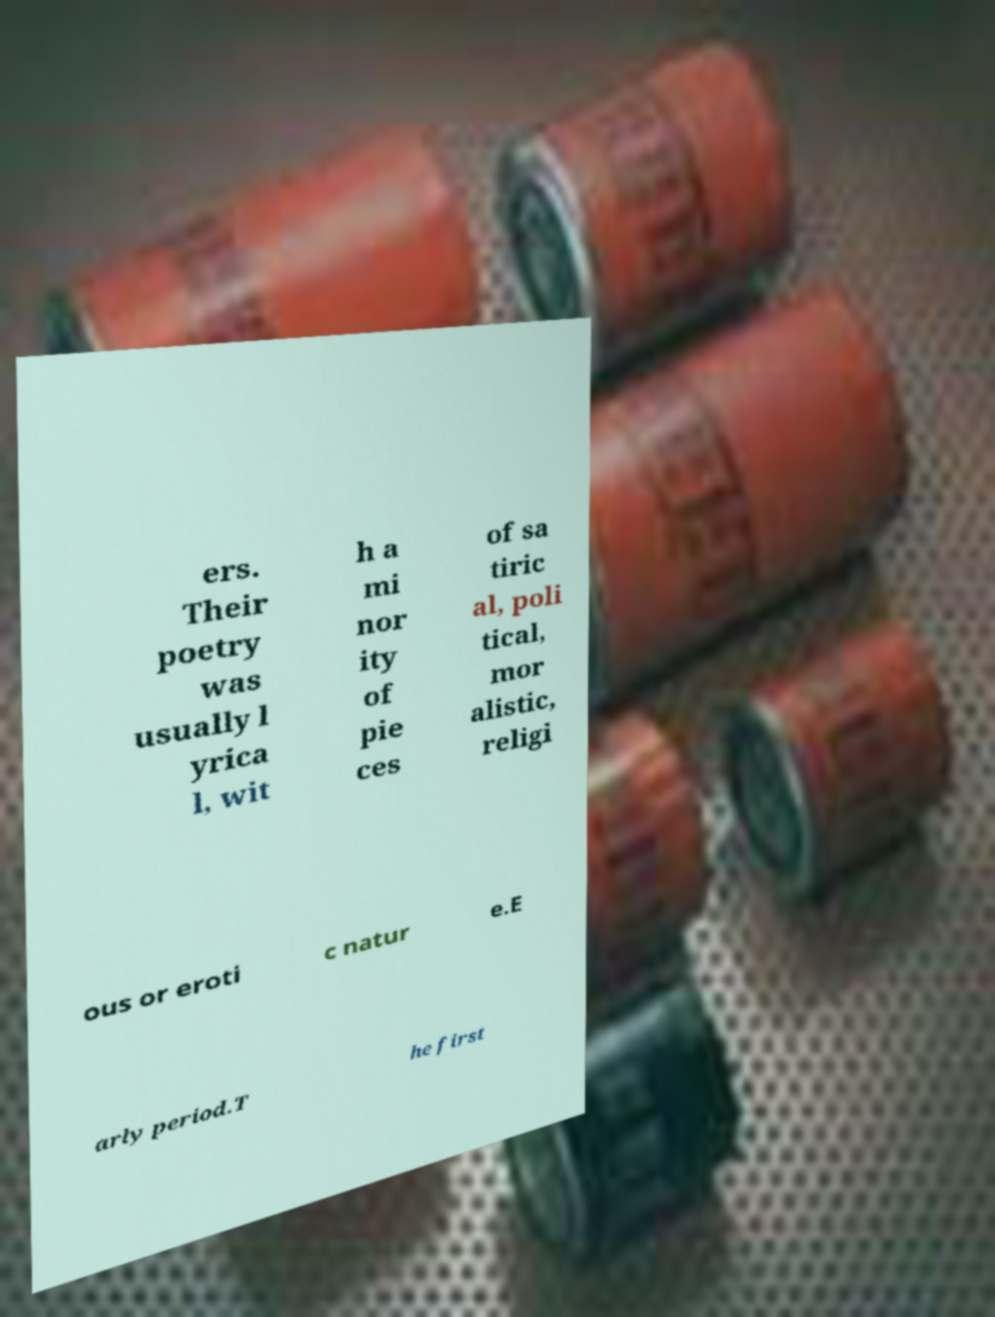What messages or text are displayed in this image? I need them in a readable, typed format. ers. Their poetry was usually l yrica l, wit h a mi nor ity of pie ces of sa tiric al, poli tical, mor alistic, religi ous or eroti c natur e.E arly period.T he first 